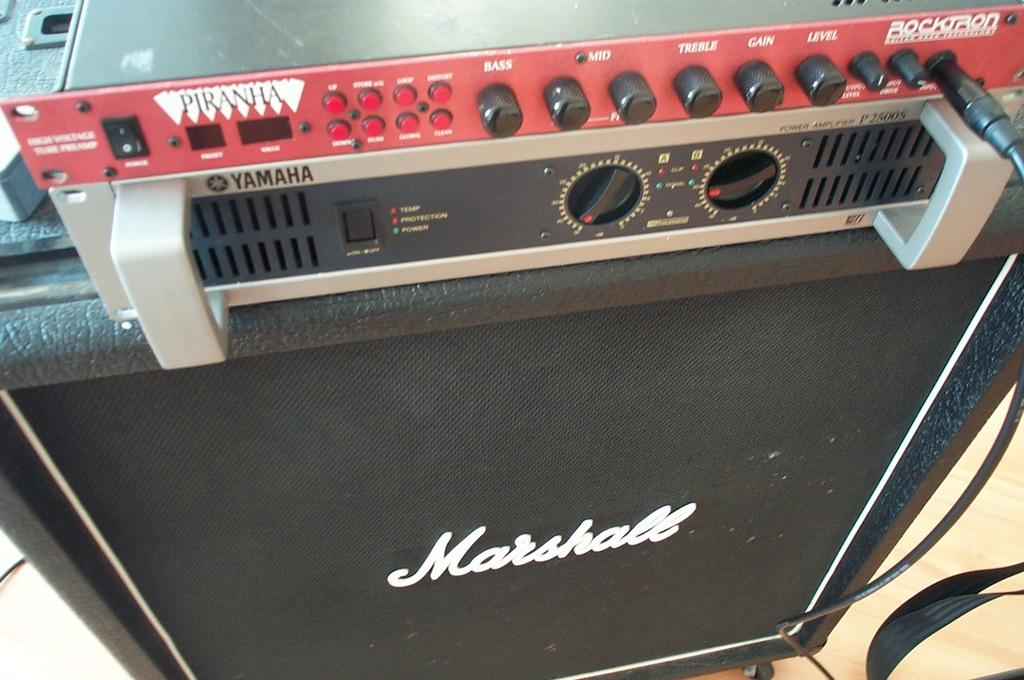<image>
Create a compact narrative representing the image presented. A piece of Yamaha equipment is on top of a Marshall amplifier. 